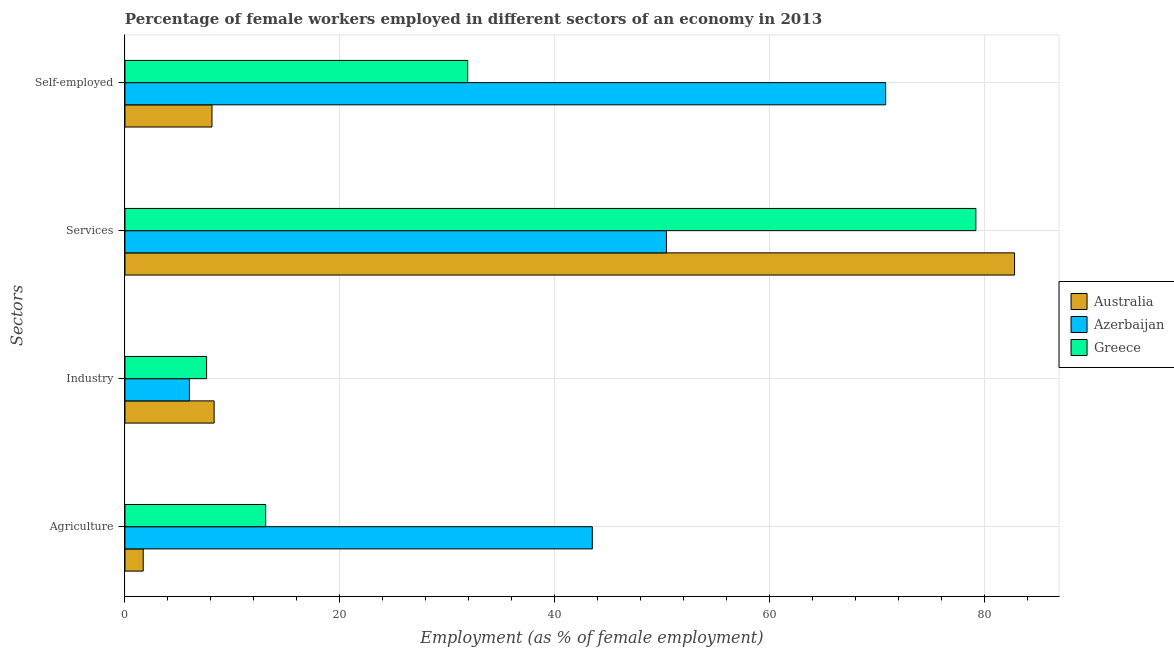How many different coloured bars are there?
Offer a terse response. 3. How many groups of bars are there?
Your answer should be compact. 4. Are the number of bars per tick equal to the number of legend labels?
Offer a very short reply. Yes. How many bars are there on the 4th tick from the bottom?
Provide a succinct answer. 3. What is the label of the 1st group of bars from the top?
Offer a very short reply. Self-employed. What is the percentage of female workers in agriculture in Australia?
Your answer should be compact. 1.7. Across all countries, what is the maximum percentage of female workers in agriculture?
Your answer should be compact. 43.5. Across all countries, what is the minimum percentage of female workers in services?
Offer a terse response. 50.4. In which country was the percentage of female workers in services minimum?
Keep it short and to the point. Azerbaijan. What is the total percentage of female workers in agriculture in the graph?
Provide a short and direct response. 58.3. What is the difference between the percentage of female workers in industry in Australia and that in Azerbaijan?
Ensure brevity in your answer.  2.3. What is the difference between the percentage of self employed female workers in Australia and the percentage of female workers in services in Azerbaijan?
Ensure brevity in your answer.  -42.3. What is the average percentage of female workers in industry per country?
Ensure brevity in your answer.  7.3. What is the difference between the percentage of female workers in agriculture and percentage of female workers in services in Australia?
Make the answer very short. -81.1. In how many countries, is the percentage of female workers in services greater than 48 %?
Offer a very short reply. 3. What is the ratio of the percentage of self employed female workers in Azerbaijan to that in Greece?
Provide a succinct answer. 2.22. Is the percentage of female workers in industry in Azerbaijan less than that in Australia?
Make the answer very short. Yes. Is the difference between the percentage of self employed female workers in Australia and Greece greater than the difference between the percentage of female workers in agriculture in Australia and Greece?
Ensure brevity in your answer.  No. What is the difference between the highest and the second highest percentage of self employed female workers?
Your answer should be compact. 38.9. What is the difference between the highest and the lowest percentage of female workers in industry?
Ensure brevity in your answer.  2.3. In how many countries, is the percentage of female workers in industry greater than the average percentage of female workers in industry taken over all countries?
Your answer should be very brief. 2. Is it the case that in every country, the sum of the percentage of female workers in industry and percentage of female workers in agriculture is greater than the sum of percentage of self employed female workers and percentage of female workers in services?
Ensure brevity in your answer.  No. What does the 2nd bar from the top in Services represents?
Make the answer very short. Azerbaijan. Are all the bars in the graph horizontal?
Your answer should be very brief. Yes. What is the difference between two consecutive major ticks on the X-axis?
Make the answer very short. 20. How many legend labels are there?
Make the answer very short. 3. How are the legend labels stacked?
Give a very brief answer. Vertical. What is the title of the graph?
Provide a succinct answer. Percentage of female workers employed in different sectors of an economy in 2013. Does "San Marino" appear as one of the legend labels in the graph?
Make the answer very short. No. What is the label or title of the X-axis?
Give a very brief answer. Employment (as % of female employment). What is the label or title of the Y-axis?
Your answer should be compact. Sectors. What is the Employment (as % of female employment) of Australia in Agriculture?
Offer a terse response. 1.7. What is the Employment (as % of female employment) of Azerbaijan in Agriculture?
Offer a terse response. 43.5. What is the Employment (as % of female employment) in Greece in Agriculture?
Make the answer very short. 13.1. What is the Employment (as % of female employment) of Australia in Industry?
Ensure brevity in your answer.  8.3. What is the Employment (as % of female employment) of Azerbaijan in Industry?
Provide a succinct answer. 6. What is the Employment (as % of female employment) of Greece in Industry?
Your response must be concise. 7.6. What is the Employment (as % of female employment) in Australia in Services?
Provide a succinct answer. 82.8. What is the Employment (as % of female employment) in Azerbaijan in Services?
Ensure brevity in your answer.  50.4. What is the Employment (as % of female employment) of Greece in Services?
Offer a very short reply. 79.2. What is the Employment (as % of female employment) in Australia in Self-employed?
Your answer should be compact. 8.1. What is the Employment (as % of female employment) of Azerbaijan in Self-employed?
Provide a short and direct response. 70.8. What is the Employment (as % of female employment) of Greece in Self-employed?
Make the answer very short. 31.9. Across all Sectors, what is the maximum Employment (as % of female employment) of Australia?
Your answer should be compact. 82.8. Across all Sectors, what is the maximum Employment (as % of female employment) of Azerbaijan?
Keep it short and to the point. 70.8. Across all Sectors, what is the maximum Employment (as % of female employment) of Greece?
Offer a terse response. 79.2. Across all Sectors, what is the minimum Employment (as % of female employment) in Australia?
Give a very brief answer. 1.7. Across all Sectors, what is the minimum Employment (as % of female employment) in Azerbaijan?
Give a very brief answer. 6. Across all Sectors, what is the minimum Employment (as % of female employment) in Greece?
Make the answer very short. 7.6. What is the total Employment (as % of female employment) in Australia in the graph?
Provide a short and direct response. 100.9. What is the total Employment (as % of female employment) of Azerbaijan in the graph?
Offer a terse response. 170.7. What is the total Employment (as % of female employment) of Greece in the graph?
Provide a succinct answer. 131.8. What is the difference between the Employment (as % of female employment) of Azerbaijan in Agriculture and that in Industry?
Make the answer very short. 37.5. What is the difference between the Employment (as % of female employment) in Greece in Agriculture and that in Industry?
Your response must be concise. 5.5. What is the difference between the Employment (as % of female employment) in Australia in Agriculture and that in Services?
Make the answer very short. -81.1. What is the difference between the Employment (as % of female employment) in Azerbaijan in Agriculture and that in Services?
Your response must be concise. -6.9. What is the difference between the Employment (as % of female employment) in Greece in Agriculture and that in Services?
Provide a succinct answer. -66.1. What is the difference between the Employment (as % of female employment) of Australia in Agriculture and that in Self-employed?
Keep it short and to the point. -6.4. What is the difference between the Employment (as % of female employment) in Azerbaijan in Agriculture and that in Self-employed?
Make the answer very short. -27.3. What is the difference between the Employment (as % of female employment) of Greece in Agriculture and that in Self-employed?
Ensure brevity in your answer.  -18.8. What is the difference between the Employment (as % of female employment) of Australia in Industry and that in Services?
Make the answer very short. -74.5. What is the difference between the Employment (as % of female employment) of Azerbaijan in Industry and that in Services?
Keep it short and to the point. -44.4. What is the difference between the Employment (as % of female employment) in Greece in Industry and that in Services?
Give a very brief answer. -71.6. What is the difference between the Employment (as % of female employment) of Azerbaijan in Industry and that in Self-employed?
Ensure brevity in your answer.  -64.8. What is the difference between the Employment (as % of female employment) in Greece in Industry and that in Self-employed?
Offer a very short reply. -24.3. What is the difference between the Employment (as % of female employment) of Australia in Services and that in Self-employed?
Give a very brief answer. 74.7. What is the difference between the Employment (as % of female employment) in Azerbaijan in Services and that in Self-employed?
Keep it short and to the point. -20.4. What is the difference between the Employment (as % of female employment) in Greece in Services and that in Self-employed?
Provide a short and direct response. 47.3. What is the difference between the Employment (as % of female employment) of Australia in Agriculture and the Employment (as % of female employment) of Azerbaijan in Industry?
Give a very brief answer. -4.3. What is the difference between the Employment (as % of female employment) in Azerbaijan in Agriculture and the Employment (as % of female employment) in Greece in Industry?
Your answer should be very brief. 35.9. What is the difference between the Employment (as % of female employment) of Australia in Agriculture and the Employment (as % of female employment) of Azerbaijan in Services?
Your answer should be compact. -48.7. What is the difference between the Employment (as % of female employment) in Australia in Agriculture and the Employment (as % of female employment) in Greece in Services?
Make the answer very short. -77.5. What is the difference between the Employment (as % of female employment) in Azerbaijan in Agriculture and the Employment (as % of female employment) in Greece in Services?
Offer a very short reply. -35.7. What is the difference between the Employment (as % of female employment) of Australia in Agriculture and the Employment (as % of female employment) of Azerbaijan in Self-employed?
Provide a succinct answer. -69.1. What is the difference between the Employment (as % of female employment) of Australia in Agriculture and the Employment (as % of female employment) of Greece in Self-employed?
Keep it short and to the point. -30.2. What is the difference between the Employment (as % of female employment) of Australia in Industry and the Employment (as % of female employment) of Azerbaijan in Services?
Provide a succinct answer. -42.1. What is the difference between the Employment (as % of female employment) in Australia in Industry and the Employment (as % of female employment) in Greece in Services?
Make the answer very short. -70.9. What is the difference between the Employment (as % of female employment) of Azerbaijan in Industry and the Employment (as % of female employment) of Greece in Services?
Your response must be concise. -73.2. What is the difference between the Employment (as % of female employment) in Australia in Industry and the Employment (as % of female employment) in Azerbaijan in Self-employed?
Ensure brevity in your answer.  -62.5. What is the difference between the Employment (as % of female employment) in Australia in Industry and the Employment (as % of female employment) in Greece in Self-employed?
Your response must be concise. -23.6. What is the difference between the Employment (as % of female employment) of Azerbaijan in Industry and the Employment (as % of female employment) of Greece in Self-employed?
Your answer should be compact. -25.9. What is the difference between the Employment (as % of female employment) of Australia in Services and the Employment (as % of female employment) of Azerbaijan in Self-employed?
Ensure brevity in your answer.  12. What is the difference between the Employment (as % of female employment) of Australia in Services and the Employment (as % of female employment) of Greece in Self-employed?
Provide a short and direct response. 50.9. What is the average Employment (as % of female employment) of Australia per Sectors?
Offer a terse response. 25.23. What is the average Employment (as % of female employment) in Azerbaijan per Sectors?
Your answer should be compact. 42.67. What is the average Employment (as % of female employment) in Greece per Sectors?
Your response must be concise. 32.95. What is the difference between the Employment (as % of female employment) in Australia and Employment (as % of female employment) in Azerbaijan in Agriculture?
Your answer should be very brief. -41.8. What is the difference between the Employment (as % of female employment) of Azerbaijan and Employment (as % of female employment) of Greece in Agriculture?
Provide a succinct answer. 30.4. What is the difference between the Employment (as % of female employment) in Australia and Employment (as % of female employment) in Azerbaijan in Industry?
Provide a succinct answer. 2.3. What is the difference between the Employment (as % of female employment) of Australia and Employment (as % of female employment) of Greece in Industry?
Ensure brevity in your answer.  0.7. What is the difference between the Employment (as % of female employment) in Australia and Employment (as % of female employment) in Azerbaijan in Services?
Offer a very short reply. 32.4. What is the difference between the Employment (as % of female employment) in Australia and Employment (as % of female employment) in Greece in Services?
Offer a very short reply. 3.6. What is the difference between the Employment (as % of female employment) of Azerbaijan and Employment (as % of female employment) of Greece in Services?
Provide a short and direct response. -28.8. What is the difference between the Employment (as % of female employment) of Australia and Employment (as % of female employment) of Azerbaijan in Self-employed?
Your answer should be very brief. -62.7. What is the difference between the Employment (as % of female employment) in Australia and Employment (as % of female employment) in Greece in Self-employed?
Make the answer very short. -23.8. What is the difference between the Employment (as % of female employment) in Azerbaijan and Employment (as % of female employment) in Greece in Self-employed?
Keep it short and to the point. 38.9. What is the ratio of the Employment (as % of female employment) in Australia in Agriculture to that in Industry?
Your response must be concise. 0.2. What is the ratio of the Employment (as % of female employment) of Azerbaijan in Agriculture to that in Industry?
Your answer should be very brief. 7.25. What is the ratio of the Employment (as % of female employment) of Greece in Agriculture to that in Industry?
Provide a succinct answer. 1.72. What is the ratio of the Employment (as % of female employment) in Australia in Agriculture to that in Services?
Give a very brief answer. 0.02. What is the ratio of the Employment (as % of female employment) in Azerbaijan in Agriculture to that in Services?
Give a very brief answer. 0.86. What is the ratio of the Employment (as % of female employment) in Greece in Agriculture to that in Services?
Provide a short and direct response. 0.17. What is the ratio of the Employment (as % of female employment) of Australia in Agriculture to that in Self-employed?
Offer a very short reply. 0.21. What is the ratio of the Employment (as % of female employment) of Azerbaijan in Agriculture to that in Self-employed?
Offer a very short reply. 0.61. What is the ratio of the Employment (as % of female employment) in Greece in Agriculture to that in Self-employed?
Make the answer very short. 0.41. What is the ratio of the Employment (as % of female employment) of Australia in Industry to that in Services?
Offer a very short reply. 0.1. What is the ratio of the Employment (as % of female employment) in Azerbaijan in Industry to that in Services?
Your answer should be very brief. 0.12. What is the ratio of the Employment (as % of female employment) of Greece in Industry to that in Services?
Keep it short and to the point. 0.1. What is the ratio of the Employment (as % of female employment) in Australia in Industry to that in Self-employed?
Provide a short and direct response. 1.02. What is the ratio of the Employment (as % of female employment) in Azerbaijan in Industry to that in Self-employed?
Provide a short and direct response. 0.08. What is the ratio of the Employment (as % of female employment) of Greece in Industry to that in Self-employed?
Ensure brevity in your answer.  0.24. What is the ratio of the Employment (as % of female employment) in Australia in Services to that in Self-employed?
Give a very brief answer. 10.22. What is the ratio of the Employment (as % of female employment) of Azerbaijan in Services to that in Self-employed?
Offer a very short reply. 0.71. What is the ratio of the Employment (as % of female employment) of Greece in Services to that in Self-employed?
Provide a succinct answer. 2.48. What is the difference between the highest and the second highest Employment (as % of female employment) of Australia?
Your answer should be compact. 74.5. What is the difference between the highest and the second highest Employment (as % of female employment) in Azerbaijan?
Offer a very short reply. 20.4. What is the difference between the highest and the second highest Employment (as % of female employment) of Greece?
Offer a very short reply. 47.3. What is the difference between the highest and the lowest Employment (as % of female employment) of Australia?
Your answer should be compact. 81.1. What is the difference between the highest and the lowest Employment (as % of female employment) of Azerbaijan?
Offer a very short reply. 64.8. What is the difference between the highest and the lowest Employment (as % of female employment) of Greece?
Offer a very short reply. 71.6. 